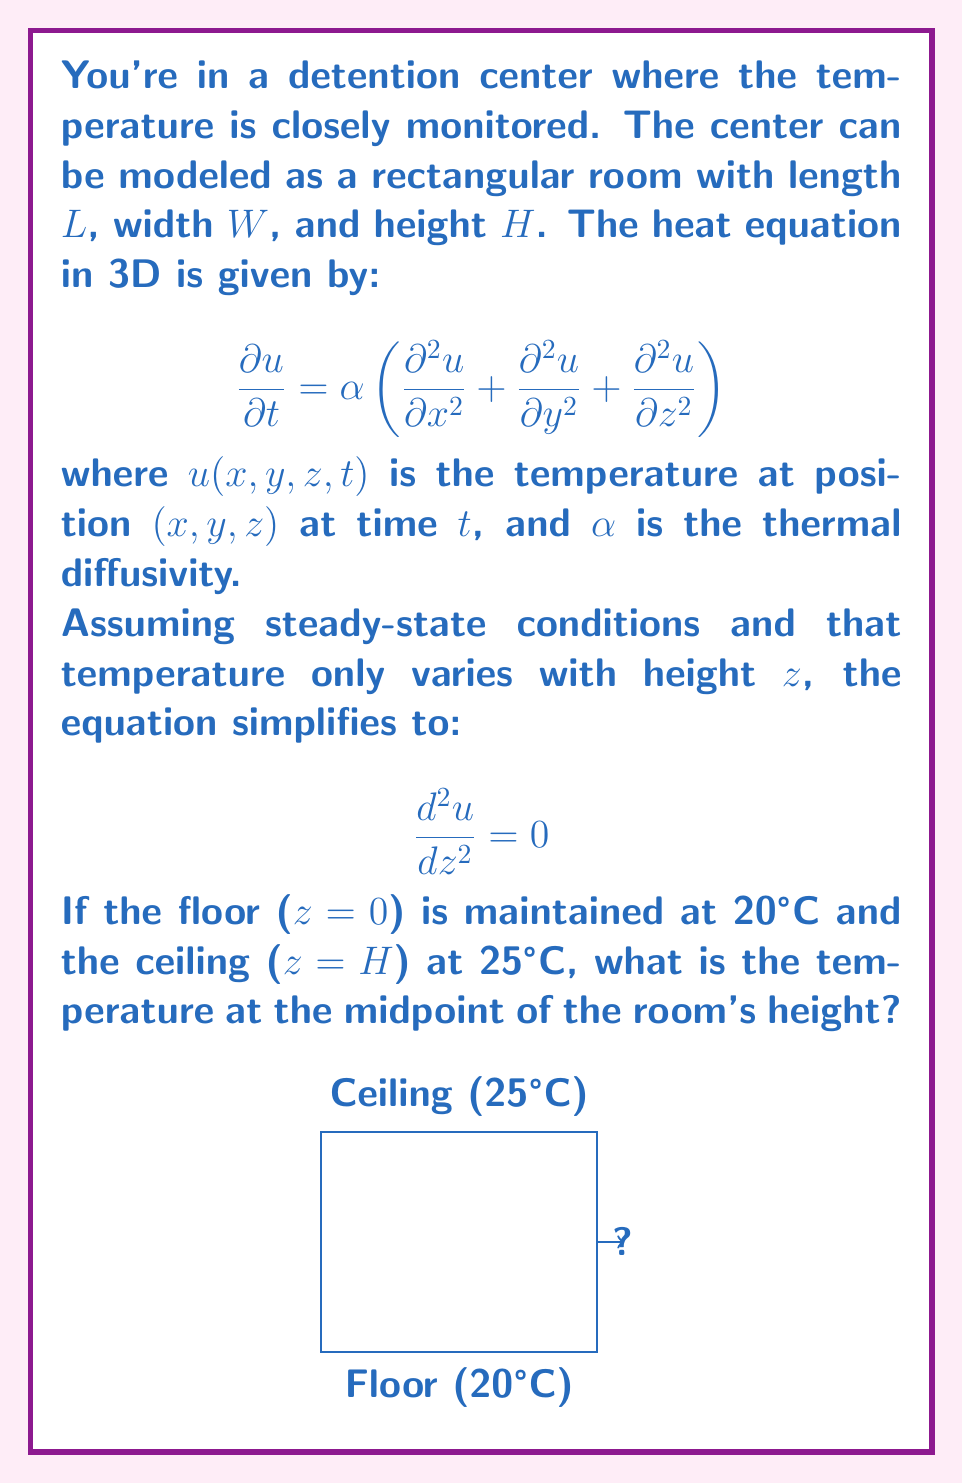Can you solve this math problem? Let's solve this step-by-step:

1) The simplified heat equation for steady-state and only z-dependence is:

   $$\frac{d^2 u}{dz^2} = 0$$

2) Integrating once:

   $$\frac{du}{dz} = C_1$$

3) Integrating again:

   $$u(z) = C_1z + C_2$$

4) We have two boundary conditions:
   - At z = 0 (floor), u = 20°C
   - At z = H (ceiling), u = 25°C

5) Applying these conditions:
   
   At z = 0: $20 = C_2$
   At z = H: $25 = C_1H + 20$

6) From the second condition:

   $$C_1 = \frac{25 - 20}{H} = \frac{5}{H}$$

7) So our solution is:

   $$u(z) = \frac{5z}{H} + 20$$

8) The midpoint of the room's height is at z = H/2. Substituting this:

   $$u(H/2) = \frac{5(H/2)}{H} + 20 = \frac{5}{2} + 20 = 22.5$$

Therefore, the temperature at the midpoint of the room's height is 22.5°C.
Answer: 22.5°C 